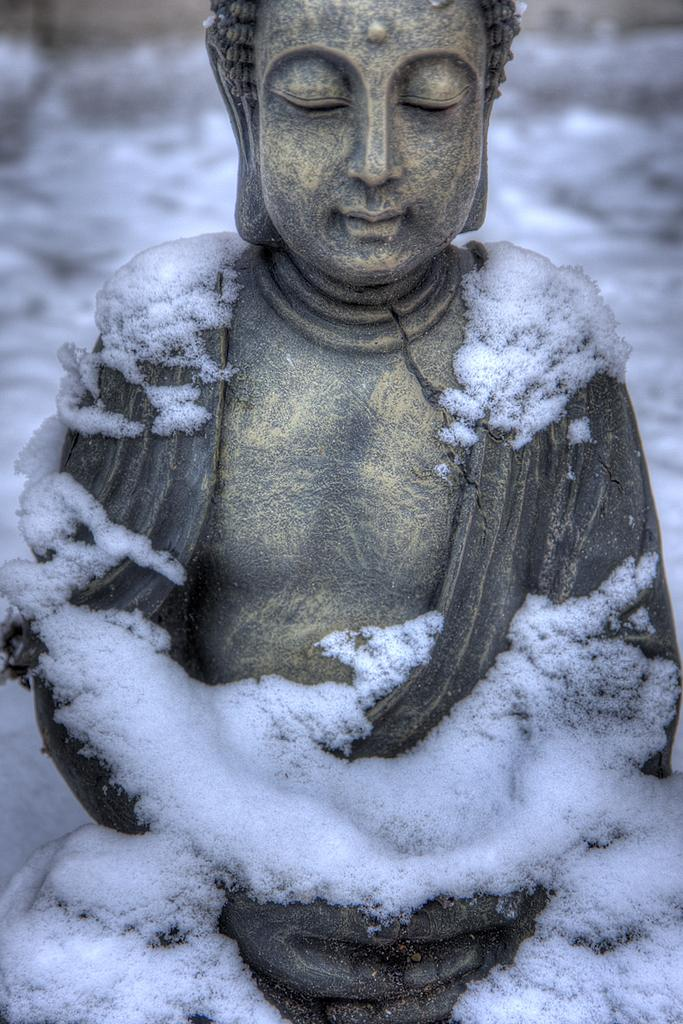What is the main subject in the image? There is a statue in the image. What is the weather condition in the image? There is snow in the image. What type of haircut does the duck have in the image? There is no duck present in the image, so it is not possible to answer that question. 